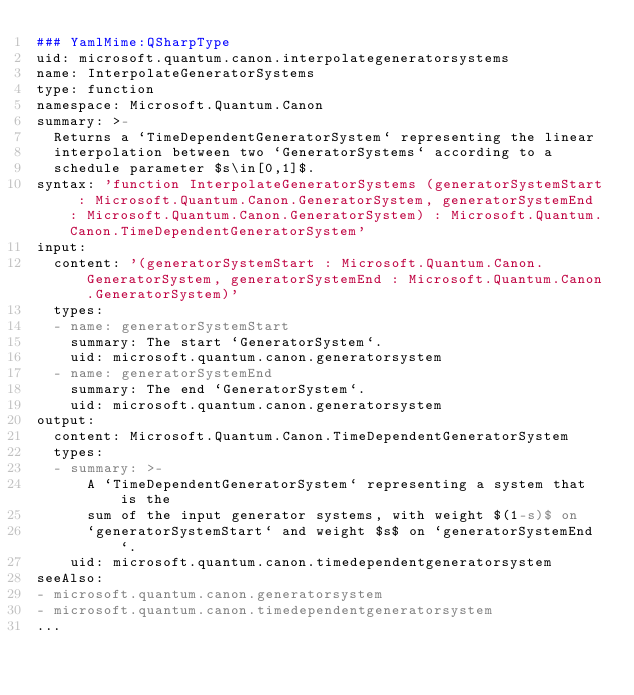Convert code to text. <code><loc_0><loc_0><loc_500><loc_500><_YAML_>### YamlMime:QSharpType
uid: microsoft.quantum.canon.interpolategeneratorsystems
name: InterpolateGeneratorSystems
type: function
namespace: Microsoft.Quantum.Canon
summary: >-
  Returns a `TimeDependentGeneratorSystem` representing the linear
  interpolation between two `GeneratorSystems` according to a
  schedule parameter $s\in[0,1]$.
syntax: 'function InterpolateGeneratorSystems (generatorSystemStart : Microsoft.Quantum.Canon.GeneratorSystem, generatorSystemEnd : Microsoft.Quantum.Canon.GeneratorSystem) : Microsoft.Quantum.Canon.TimeDependentGeneratorSystem'
input:
  content: '(generatorSystemStart : Microsoft.Quantum.Canon.GeneratorSystem, generatorSystemEnd : Microsoft.Quantum.Canon.GeneratorSystem)'
  types:
  - name: generatorSystemStart
    summary: The start `GeneratorSystem`.
    uid: microsoft.quantum.canon.generatorsystem
  - name: generatorSystemEnd
    summary: The end `GeneratorSystem`.
    uid: microsoft.quantum.canon.generatorsystem
output:
  content: Microsoft.Quantum.Canon.TimeDependentGeneratorSystem
  types:
  - summary: >-
      A `TimeDependentGeneratorSystem` representing a system that is the
      sum of the input generator systems, with weight $(1-s)$ on
      `generatorSystemStart` and weight $s$ on `generatorSystemEnd`.
    uid: microsoft.quantum.canon.timedependentgeneratorsystem
seeAlso:
- microsoft.quantum.canon.generatorsystem
- microsoft.quantum.canon.timedependentgeneratorsystem
...
</code> 